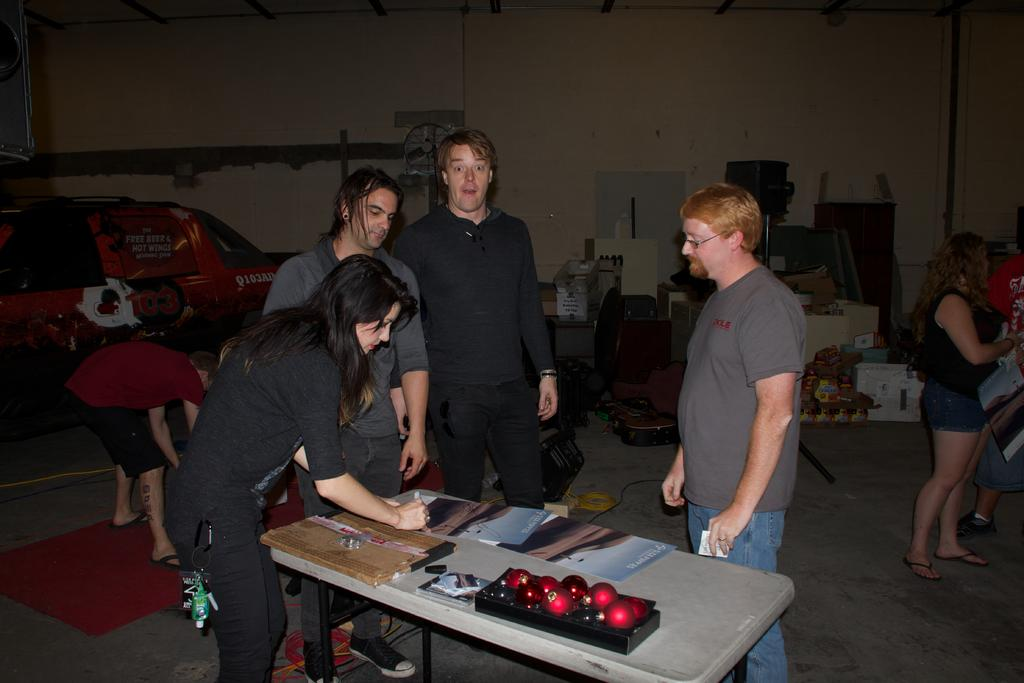What can be seen in the image involving people? There are persons standing in the image. What objects are present on the table? There is a ball, a box, and a book on the table. What is on the floor in the image? There are things on the floor, and there is a red carpet. Is there anything visible in the distance? Yes, there is a vehicle visible in the distance. Are there any laborers working in the cellar shown in the image? There is no cellar or laborers present in the image. Can you see any clams on the red carpet in the image? There are no clams visible on the red carpet in the image. 